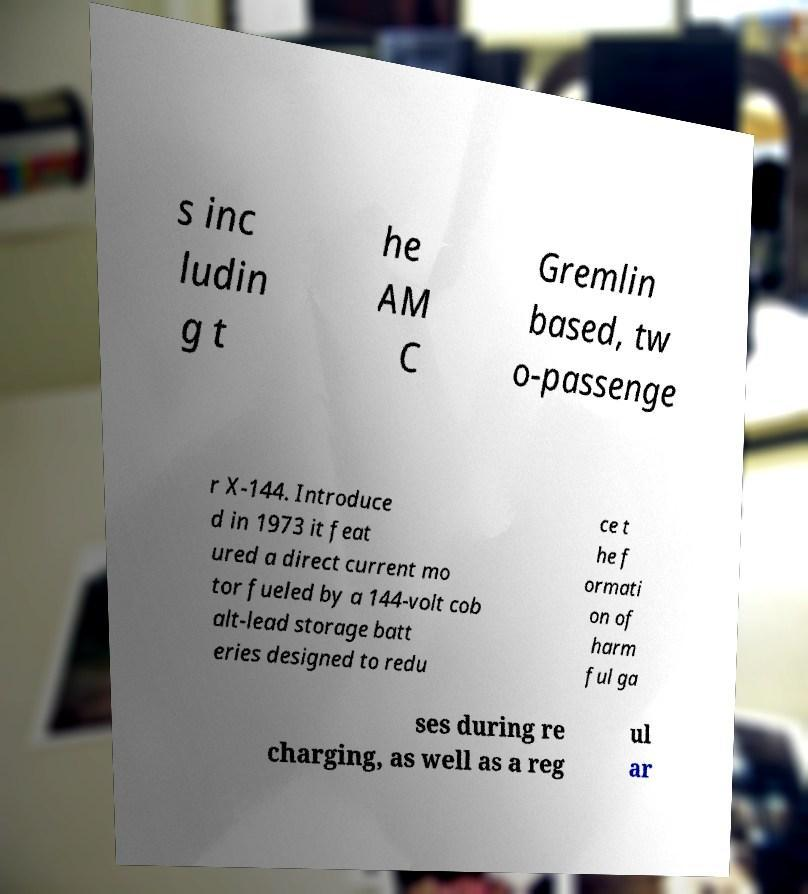Can you accurately transcribe the text from the provided image for me? s inc ludin g t he AM C Gremlin based, tw o-passenge r X-144. Introduce d in 1973 it feat ured a direct current mo tor fueled by a 144-volt cob alt-lead storage batt eries designed to redu ce t he f ormati on of harm ful ga ses during re charging, as well as a reg ul ar 